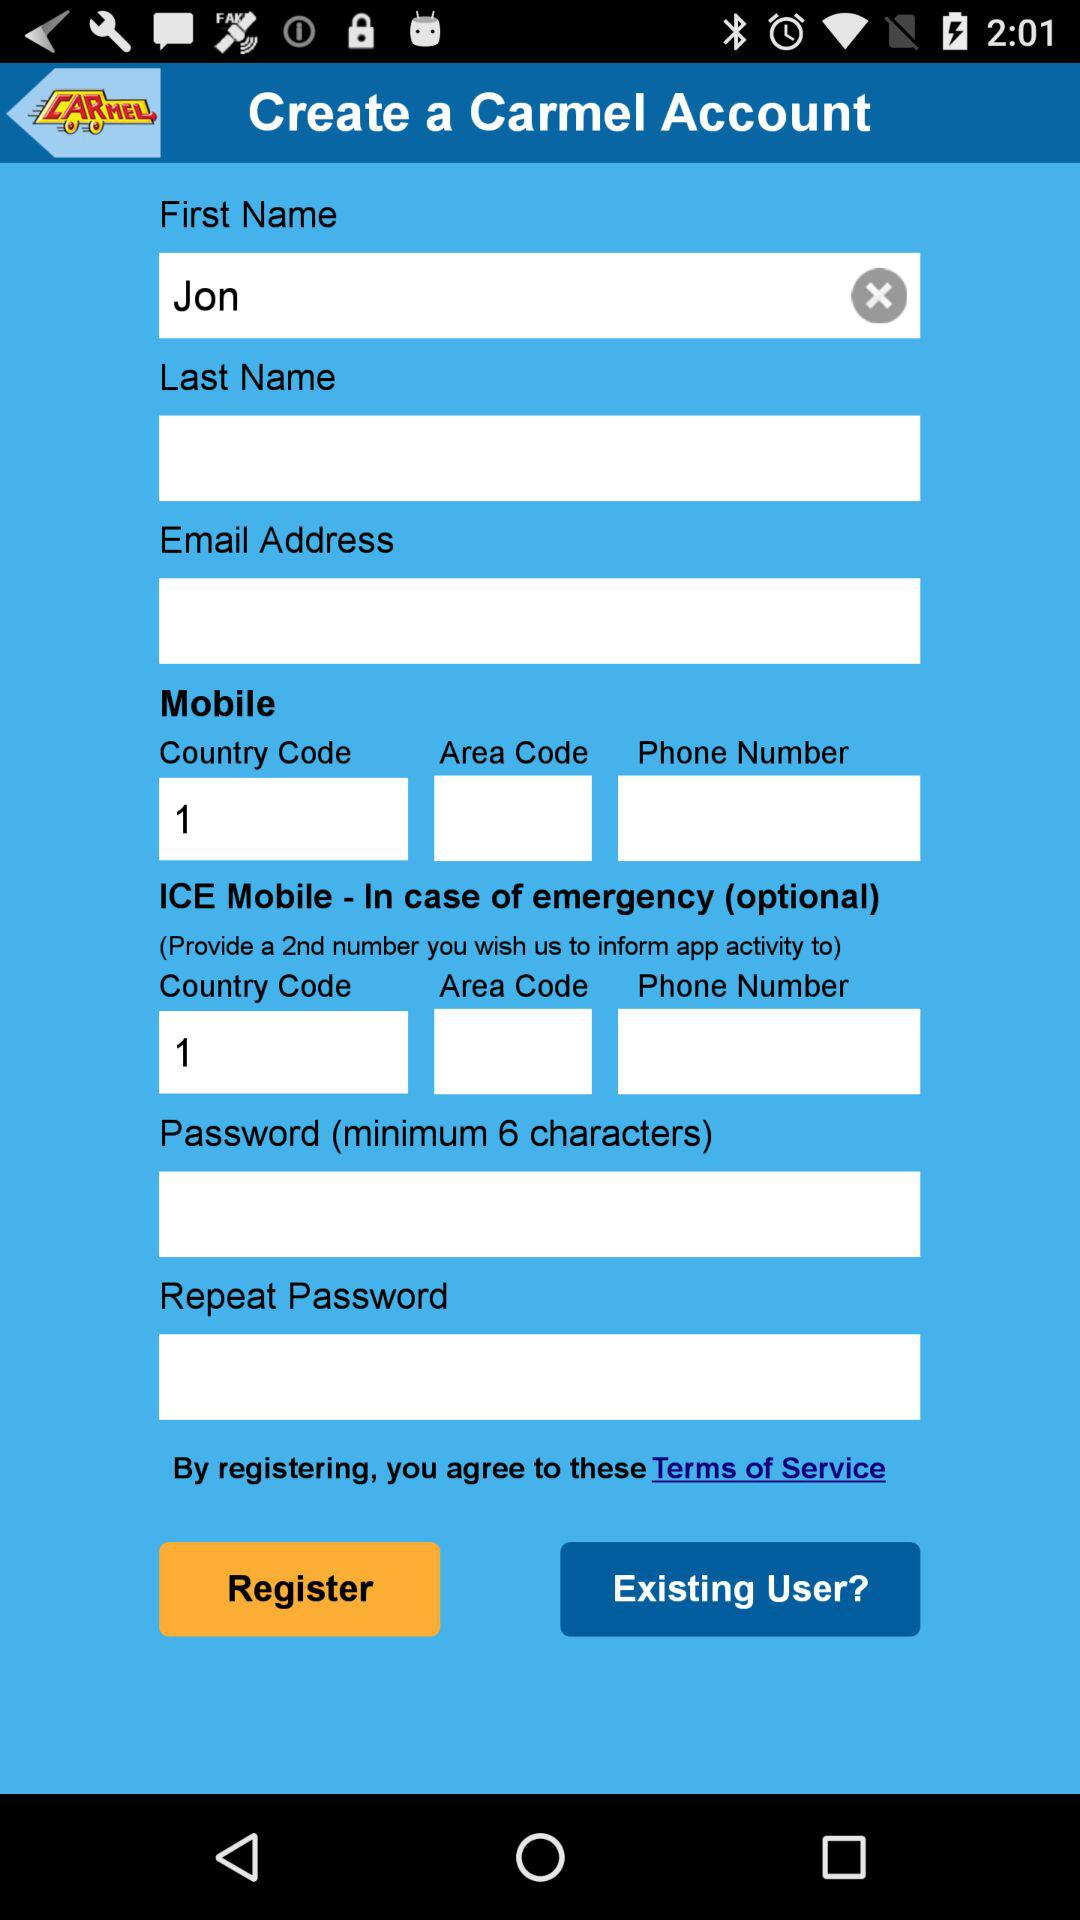What is the country code? The country code is 1. 